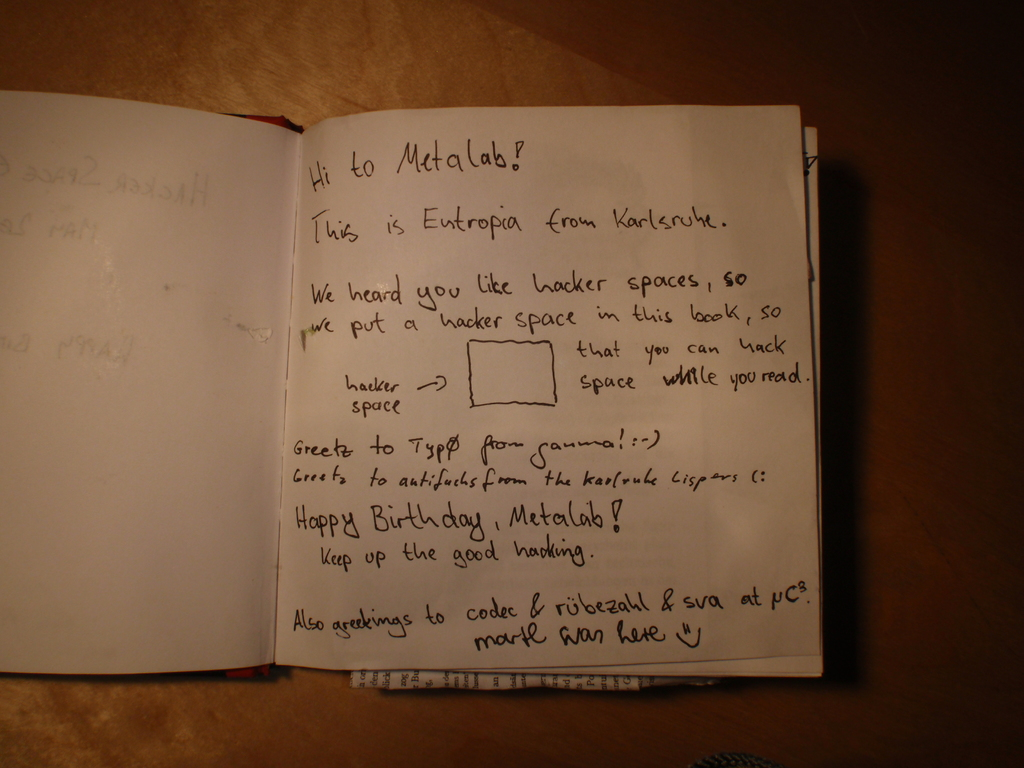Describe the following image. The image shows a heartfelt handwritten note within an open notebook. The note, written in a casual, friendly handwriting with a black pen, is from a group called 'Entropia' based in Karlsruhe to 'Metalab'. It expresses Entropia's recognition of Metalab's interest in hacker spaces and mentions that they have included a hacker space within the notebook itself, suggesting humor and creativity. This space is humorously designed to allow hacking while reading. The note also extends warm birthday wishes to Metalab, praises their endeavors in hacking, and encourages them to persist. Greetings are also sent to individuals and groups associated with PyCon and other communities, illustrating a network of camaraderie and mutual appreciation among tech enthusiasts. 